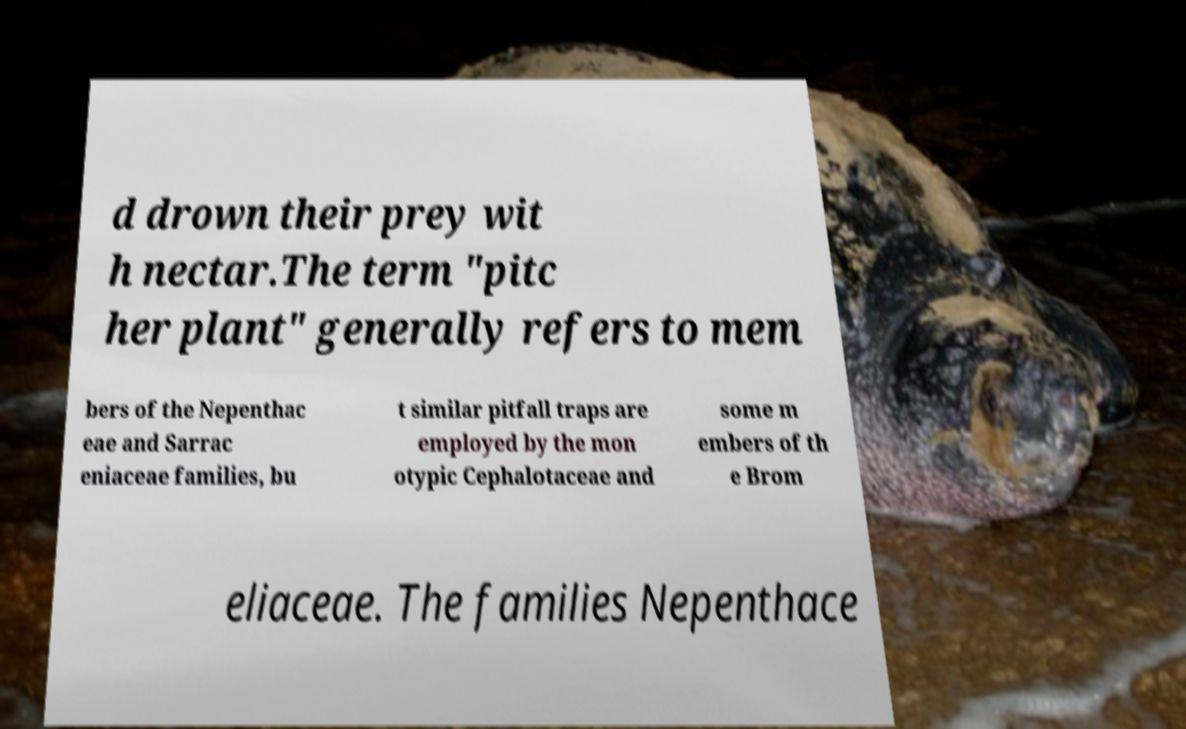Can you read and provide the text displayed in the image?This photo seems to have some interesting text. Can you extract and type it out for me? d drown their prey wit h nectar.The term "pitc her plant" generally refers to mem bers of the Nepenthac eae and Sarrac eniaceae families, bu t similar pitfall traps are employed by the mon otypic Cephalotaceae and some m embers of th e Brom eliaceae. The families Nepenthace 